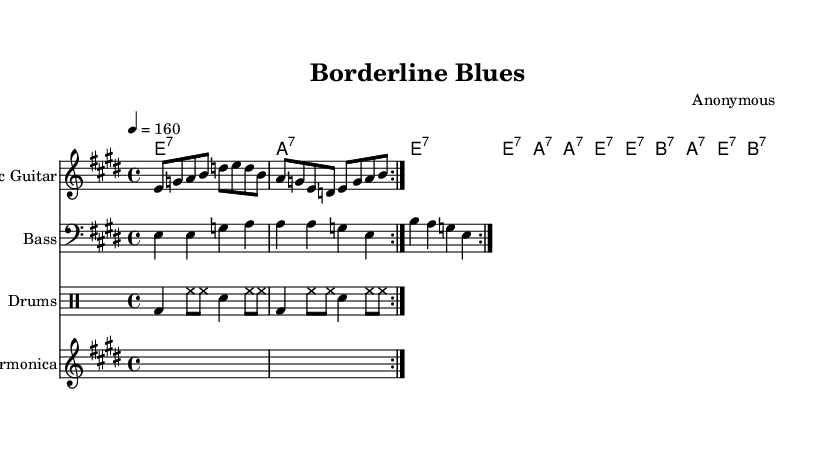What is the key signature of this music? The key signature indicated in the music is E major, which has four sharps (F#, C#, G#, D#). This can be determined by looking at the key signature shown at the beginning of the staves.
Answer: E major What is the time signature of this music? The time signature displayed in the sheet music is 4/4, which is shown at the beginning of the score right after the key signature. This indicates that there are four beats in each measure, and the quarter note gets one beat.
Answer: 4/4 What is the tempo marking for this piece? The tempo marking, shown at the beginning of the score, states "4 = 160." This indicates that there are 160 beats per minute, meaning the piece is played quite fast.
Answer: 160 How many measures does the electric guitar part repeat? The electric guitar part has a repeat indication denoted by the volta markings. Specifically, it is indicated to repeat two times in the score.
Answer: 2 What type of musical genre is indicated by the title? The title "Borderline Blues" suggests that this is a blues piece, specifically within the electric blues genre. This can be inferred from the word "Blues" in the title.
Answer: Electric Blues What is the role of the harmonica in this piece? The harmonica part is indicated as a placeholder without any written notes, suggesting that it is meant to provide atmosphere or specific sounds typical in blues music but has not been notated in this particular score.
Answer: Placeholder 